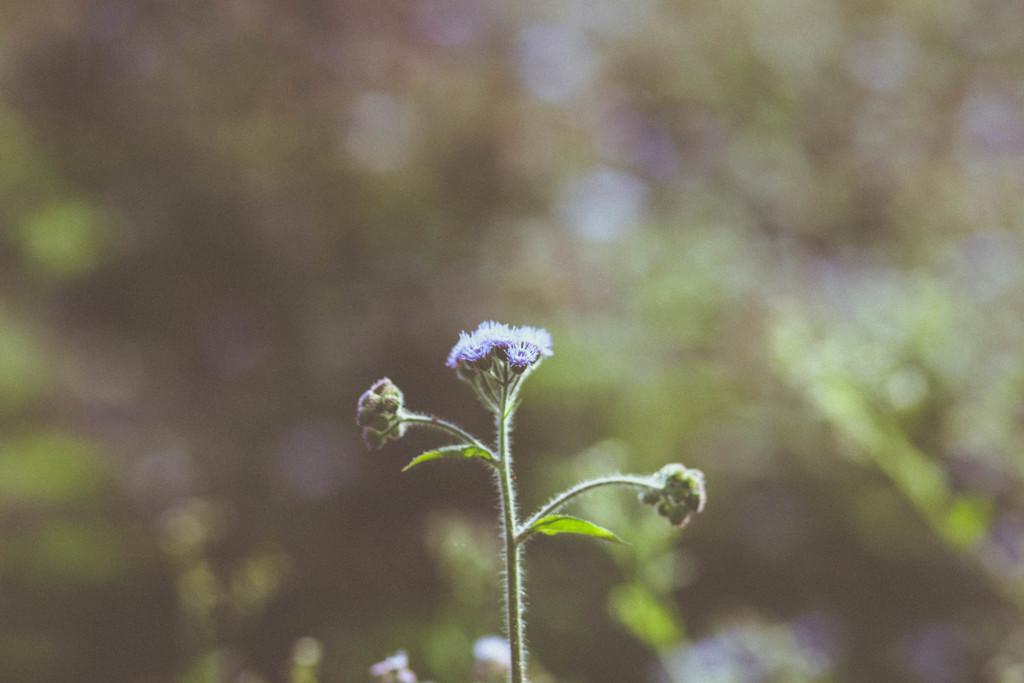Please provide a concise description of this image. In this picture we can see flowers, leaves and in the background it is blurry. 